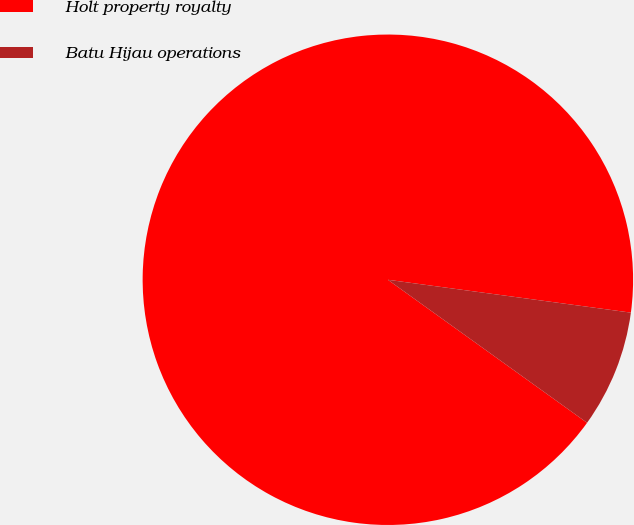Convert chart. <chart><loc_0><loc_0><loc_500><loc_500><pie_chart><fcel>Holt property royalty<fcel>Batu Hijau operations<nl><fcel>92.23%<fcel>7.77%<nl></chart> 